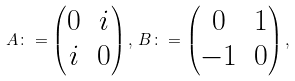<formula> <loc_0><loc_0><loc_500><loc_500>A \colon = \begin{pmatrix} 0 & i \\ i & 0 \end{pmatrix} , \, B \colon = \begin{pmatrix} 0 & 1 \\ - 1 & 0 \end{pmatrix} ,</formula> 